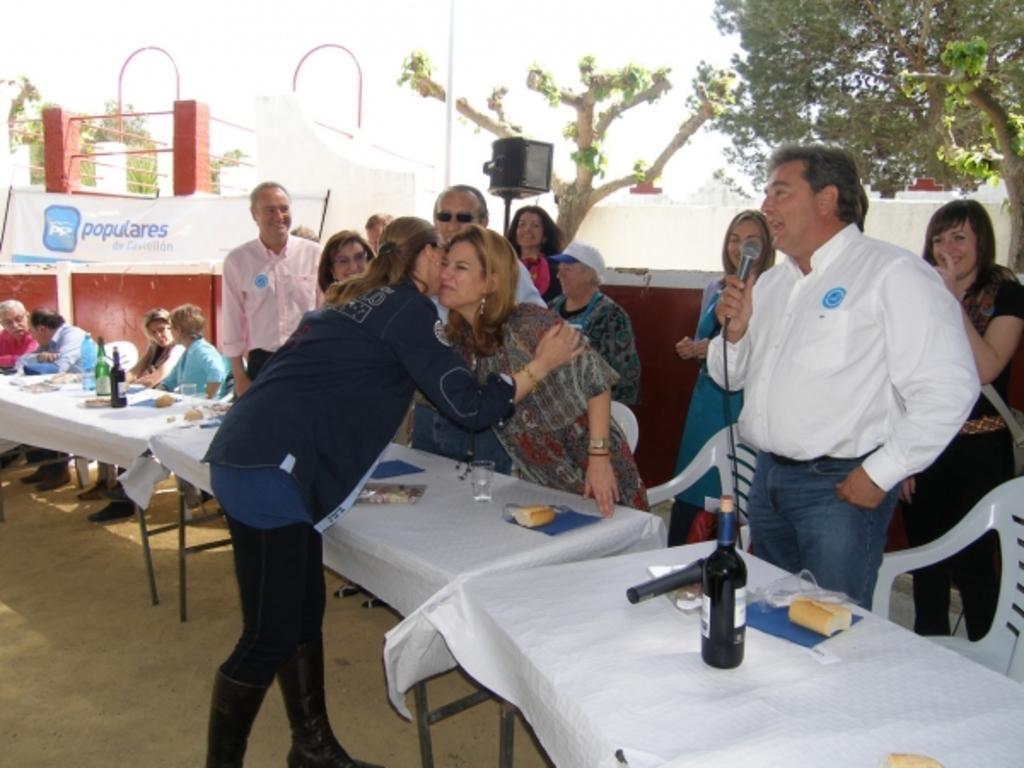In one or two sentences, can you explain what this image depicts? There are group of people standing. This is a table covered with white cloth. This is a wine bottle,the milk ,food and some things on it. This looks like a speaker. This is the banner hanging. Here are few people sitting on the chairs. This is the tree. 